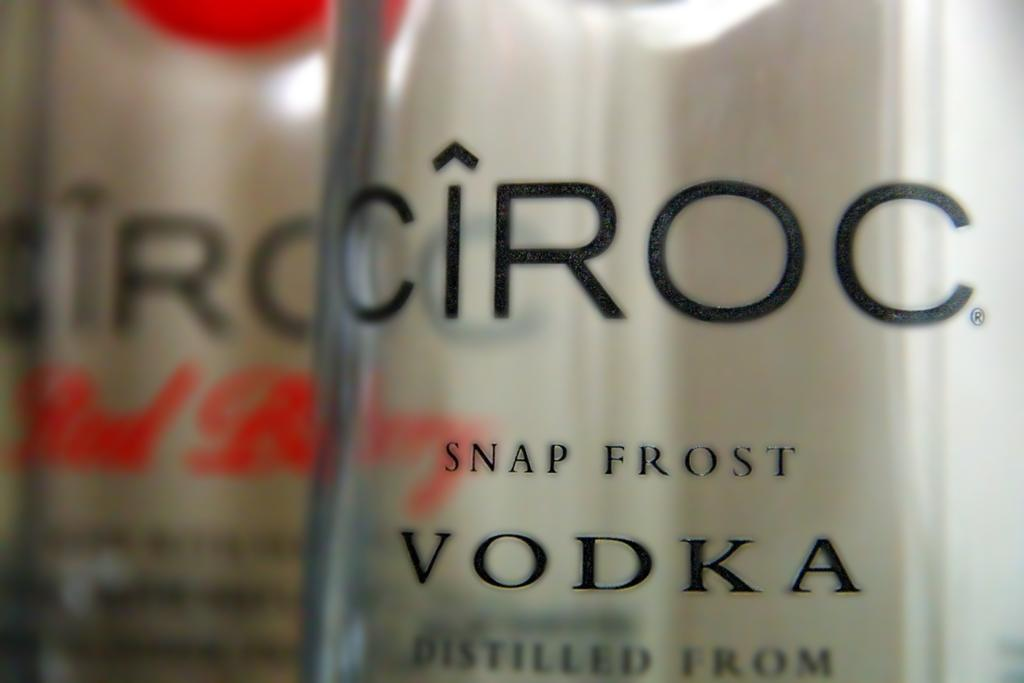Provide a one-sentence caption for the provided image. A close up of bottle of Ciroc Snap Frost Vodka. 